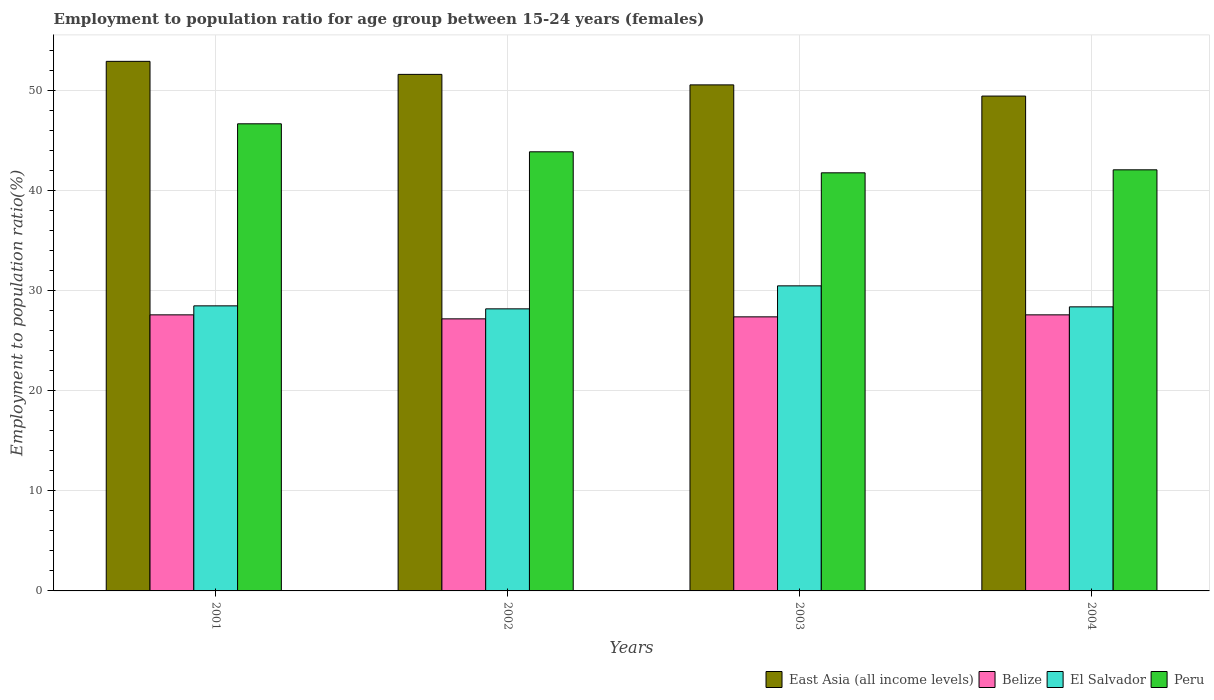How many groups of bars are there?
Make the answer very short. 4. Across all years, what is the maximum employment to population ratio in El Salvador?
Offer a terse response. 30.5. Across all years, what is the minimum employment to population ratio in El Salvador?
Your answer should be compact. 28.2. In which year was the employment to population ratio in El Salvador maximum?
Give a very brief answer. 2003. In which year was the employment to population ratio in Peru minimum?
Give a very brief answer. 2003. What is the total employment to population ratio in East Asia (all income levels) in the graph?
Give a very brief answer. 204.65. What is the difference between the employment to population ratio in Peru in 2001 and that in 2004?
Offer a terse response. 4.6. What is the difference between the employment to population ratio in Belize in 2003 and the employment to population ratio in Peru in 2001?
Provide a short and direct response. -19.3. What is the average employment to population ratio in El Salvador per year?
Your response must be concise. 28.9. In the year 2002, what is the difference between the employment to population ratio in Peru and employment to population ratio in Belize?
Offer a terse response. 16.7. In how many years, is the employment to population ratio in East Asia (all income levels) greater than 44 %?
Your answer should be compact. 4. What is the ratio of the employment to population ratio in Peru in 2003 to that in 2004?
Your response must be concise. 0.99. What is the difference between the highest and the second highest employment to population ratio in Peru?
Make the answer very short. 2.8. What is the difference between the highest and the lowest employment to population ratio in Peru?
Your answer should be compact. 4.9. In how many years, is the employment to population ratio in East Asia (all income levels) greater than the average employment to population ratio in East Asia (all income levels) taken over all years?
Offer a terse response. 2. What does the 2nd bar from the left in 2004 represents?
Provide a short and direct response. Belize. What does the 1st bar from the right in 2003 represents?
Your answer should be very brief. Peru. Is it the case that in every year, the sum of the employment to population ratio in East Asia (all income levels) and employment to population ratio in El Salvador is greater than the employment to population ratio in Belize?
Make the answer very short. Yes. Are the values on the major ticks of Y-axis written in scientific E-notation?
Your answer should be very brief. No. How many legend labels are there?
Provide a succinct answer. 4. What is the title of the graph?
Ensure brevity in your answer.  Employment to population ratio for age group between 15-24 years (females). What is the label or title of the Y-axis?
Your answer should be compact. Employment to population ratio(%). What is the Employment to population ratio(%) in East Asia (all income levels) in 2001?
Your response must be concise. 52.94. What is the Employment to population ratio(%) in Belize in 2001?
Your answer should be compact. 27.6. What is the Employment to population ratio(%) in El Salvador in 2001?
Offer a terse response. 28.5. What is the Employment to population ratio(%) in Peru in 2001?
Ensure brevity in your answer.  46.7. What is the Employment to population ratio(%) in East Asia (all income levels) in 2002?
Offer a terse response. 51.64. What is the Employment to population ratio(%) in Belize in 2002?
Your answer should be compact. 27.2. What is the Employment to population ratio(%) of El Salvador in 2002?
Give a very brief answer. 28.2. What is the Employment to population ratio(%) of Peru in 2002?
Offer a terse response. 43.9. What is the Employment to population ratio(%) of East Asia (all income levels) in 2003?
Offer a terse response. 50.59. What is the Employment to population ratio(%) in Belize in 2003?
Offer a terse response. 27.4. What is the Employment to population ratio(%) of El Salvador in 2003?
Your answer should be compact. 30.5. What is the Employment to population ratio(%) in Peru in 2003?
Ensure brevity in your answer.  41.8. What is the Employment to population ratio(%) of East Asia (all income levels) in 2004?
Provide a succinct answer. 49.47. What is the Employment to population ratio(%) of Belize in 2004?
Offer a very short reply. 27.6. What is the Employment to population ratio(%) in El Salvador in 2004?
Give a very brief answer. 28.4. What is the Employment to population ratio(%) of Peru in 2004?
Your response must be concise. 42.1. Across all years, what is the maximum Employment to population ratio(%) of East Asia (all income levels)?
Your answer should be very brief. 52.94. Across all years, what is the maximum Employment to population ratio(%) in Belize?
Ensure brevity in your answer.  27.6. Across all years, what is the maximum Employment to population ratio(%) in El Salvador?
Keep it short and to the point. 30.5. Across all years, what is the maximum Employment to population ratio(%) in Peru?
Keep it short and to the point. 46.7. Across all years, what is the minimum Employment to population ratio(%) of East Asia (all income levels)?
Make the answer very short. 49.47. Across all years, what is the minimum Employment to population ratio(%) of Belize?
Offer a terse response. 27.2. Across all years, what is the minimum Employment to population ratio(%) in El Salvador?
Keep it short and to the point. 28.2. Across all years, what is the minimum Employment to population ratio(%) in Peru?
Provide a succinct answer. 41.8. What is the total Employment to population ratio(%) in East Asia (all income levels) in the graph?
Ensure brevity in your answer.  204.65. What is the total Employment to population ratio(%) of Belize in the graph?
Provide a short and direct response. 109.8. What is the total Employment to population ratio(%) of El Salvador in the graph?
Provide a short and direct response. 115.6. What is the total Employment to population ratio(%) in Peru in the graph?
Give a very brief answer. 174.5. What is the difference between the Employment to population ratio(%) of East Asia (all income levels) in 2001 and that in 2002?
Your response must be concise. 1.3. What is the difference between the Employment to population ratio(%) of Belize in 2001 and that in 2002?
Keep it short and to the point. 0.4. What is the difference between the Employment to population ratio(%) in East Asia (all income levels) in 2001 and that in 2003?
Make the answer very short. 2.35. What is the difference between the Employment to population ratio(%) of El Salvador in 2001 and that in 2003?
Give a very brief answer. -2. What is the difference between the Employment to population ratio(%) of Peru in 2001 and that in 2003?
Give a very brief answer. 4.9. What is the difference between the Employment to population ratio(%) of East Asia (all income levels) in 2001 and that in 2004?
Ensure brevity in your answer.  3.47. What is the difference between the Employment to population ratio(%) of Peru in 2001 and that in 2004?
Your answer should be compact. 4.6. What is the difference between the Employment to population ratio(%) of East Asia (all income levels) in 2002 and that in 2003?
Provide a succinct answer. 1.05. What is the difference between the Employment to population ratio(%) of Belize in 2002 and that in 2003?
Give a very brief answer. -0.2. What is the difference between the Employment to population ratio(%) in El Salvador in 2002 and that in 2003?
Ensure brevity in your answer.  -2.3. What is the difference between the Employment to population ratio(%) of East Asia (all income levels) in 2002 and that in 2004?
Ensure brevity in your answer.  2.17. What is the difference between the Employment to population ratio(%) in El Salvador in 2002 and that in 2004?
Give a very brief answer. -0.2. What is the difference between the Employment to population ratio(%) of East Asia (all income levels) in 2003 and that in 2004?
Provide a succinct answer. 1.12. What is the difference between the Employment to population ratio(%) of Belize in 2003 and that in 2004?
Make the answer very short. -0.2. What is the difference between the Employment to population ratio(%) of Peru in 2003 and that in 2004?
Your answer should be very brief. -0.3. What is the difference between the Employment to population ratio(%) of East Asia (all income levels) in 2001 and the Employment to population ratio(%) of Belize in 2002?
Make the answer very short. 25.74. What is the difference between the Employment to population ratio(%) of East Asia (all income levels) in 2001 and the Employment to population ratio(%) of El Salvador in 2002?
Provide a short and direct response. 24.74. What is the difference between the Employment to population ratio(%) in East Asia (all income levels) in 2001 and the Employment to population ratio(%) in Peru in 2002?
Give a very brief answer. 9.04. What is the difference between the Employment to population ratio(%) in Belize in 2001 and the Employment to population ratio(%) in Peru in 2002?
Offer a terse response. -16.3. What is the difference between the Employment to population ratio(%) of El Salvador in 2001 and the Employment to population ratio(%) of Peru in 2002?
Keep it short and to the point. -15.4. What is the difference between the Employment to population ratio(%) in East Asia (all income levels) in 2001 and the Employment to population ratio(%) in Belize in 2003?
Your response must be concise. 25.54. What is the difference between the Employment to population ratio(%) in East Asia (all income levels) in 2001 and the Employment to population ratio(%) in El Salvador in 2003?
Keep it short and to the point. 22.44. What is the difference between the Employment to population ratio(%) in East Asia (all income levels) in 2001 and the Employment to population ratio(%) in Peru in 2003?
Your answer should be compact. 11.14. What is the difference between the Employment to population ratio(%) in East Asia (all income levels) in 2001 and the Employment to population ratio(%) in Belize in 2004?
Provide a succinct answer. 25.34. What is the difference between the Employment to population ratio(%) of East Asia (all income levels) in 2001 and the Employment to population ratio(%) of El Salvador in 2004?
Your answer should be compact. 24.54. What is the difference between the Employment to population ratio(%) in East Asia (all income levels) in 2001 and the Employment to population ratio(%) in Peru in 2004?
Keep it short and to the point. 10.84. What is the difference between the Employment to population ratio(%) in Belize in 2001 and the Employment to population ratio(%) in Peru in 2004?
Give a very brief answer. -14.5. What is the difference between the Employment to population ratio(%) in El Salvador in 2001 and the Employment to population ratio(%) in Peru in 2004?
Offer a very short reply. -13.6. What is the difference between the Employment to population ratio(%) of East Asia (all income levels) in 2002 and the Employment to population ratio(%) of Belize in 2003?
Make the answer very short. 24.24. What is the difference between the Employment to population ratio(%) of East Asia (all income levels) in 2002 and the Employment to population ratio(%) of El Salvador in 2003?
Make the answer very short. 21.14. What is the difference between the Employment to population ratio(%) of East Asia (all income levels) in 2002 and the Employment to population ratio(%) of Peru in 2003?
Offer a terse response. 9.84. What is the difference between the Employment to population ratio(%) of Belize in 2002 and the Employment to population ratio(%) of Peru in 2003?
Your answer should be compact. -14.6. What is the difference between the Employment to population ratio(%) of East Asia (all income levels) in 2002 and the Employment to population ratio(%) of Belize in 2004?
Offer a terse response. 24.04. What is the difference between the Employment to population ratio(%) in East Asia (all income levels) in 2002 and the Employment to population ratio(%) in El Salvador in 2004?
Offer a terse response. 23.24. What is the difference between the Employment to population ratio(%) in East Asia (all income levels) in 2002 and the Employment to population ratio(%) in Peru in 2004?
Your answer should be very brief. 9.54. What is the difference between the Employment to population ratio(%) in Belize in 2002 and the Employment to population ratio(%) in El Salvador in 2004?
Your answer should be compact. -1.2. What is the difference between the Employment to population ratio(%) of Belize in 2002 and the Employment to population ratio(%) of Peru in 2004?
Make the answer very short. -14.9. What is the difference between the Employment to population ratio(%) of East Asia (all income levels) in 2003 and the Employment to population ratio(%) of Belize in 2004?
Offer a terse response. 22.99. What is the difference between the Employment to population ratio(%) in East Asia (all income levels) in 2003 and the Employment to population ratio(%) in El Salvador in 2004?
Ensure brevity in your answer.  22.19. What is the difference between the Employment to population ratio(%) in East Asia (all income levels) in 2003 and the Employment to population ratio(%) in Peru in 2004?
Give a very brief answer. 8.49. What is the difference between the Employment to population ratio(%) of Belize in 2003 and the Employment to population ratio(%) of El Salvador in 2004?
Your answer should be compact. -1. What is the difference between the Employment to population ratio(%) of Belize in 2003 and the Employment to population ratio(%) of Peru in 2004?
Provide a succinct answer. -14.7. What is the difference between the Employment to population ratio(%) in El Salvador in 2003 and the Employment to population ratio(%) in Peru in 2004?
Give a very brief answer. -11.6. What is the average Employment to population ratio(%) of East Asia (all income levels) per year?
Make the answer very short. 51.16. What is the average Employment to population ratio(%) in Belize per year?
Make the answer very short. 27.45. What is the average Employment to population ratio(%) of El Salvador per year?
Offer a very short reply. 28.9. What is the average Employment to population ratio(%) of Peru per year?
Keep it short and to the point. 43.62. In the year 2001, what is the difference between the Employment to population ratio(%) of East Asia (all income levels) and Employment to population ratio(%) of Belize?
Offer a terse response. 25.34. In the year 2001, what is the difference between the Employment to population ratio(%) of East Asia (all income levels) and Employment to population ratio(%) of El Salvador?
Keep it short and to the point. 24.44. In the year 2001, what is the difference between the Employment to population ratio(%) of East Asia (all income levels) and Employment to population ratio(%) of Peru?
Offer a terse response. 6.24. In the year 2001, what is the difference between the Employment to population ratio(%) of Belize and Employment to population ratio(%) of El Salvador?
Provide a short and direct response. -0.9. In the year 2001, what is the difference between the Employment to population ratio(%) in Belize and Employment to population ratio(%) in Peru?
Make the answer very short. -19.1. In the year 2001, what is the difference between the Employment to population ratio(%) in El Salvador and Employment to population ratio(%) in Peru?
Your response must be concise. -18.2. In the year 2002, what is the difference between the Employment to population ratio(%) of East Asia (all income levels) and Employment to population ratio(%) of Belize?
Give a very brief answer. 24.44. In the year 2002, what is the difference between the Employment to population ratio(%) of East Asia (all income levels) and Employment to population ratio(%) of El Salvador?
Provide a succinct answer. 23.44. In the year 2002, what is the difference between the Employment to population ratio(%) in East Asia (all income levels) and Employment to population ratio(%) in Peru?
Provide a short and direct response. 7.74. In the year 2002, what is the difference between the Employment to population ratio(%) of Belize and Employment to population ratio(%) of El Salvador?
Provide a succinct answer. -1. In the year 2002, what is the difference between the Employment to population ratio(%) of Belize and Employment to population ratio(%) of Peru?
Keep it short and to the point. -16.7. In the year 2002, what is the difference between the Employment to population ratio(%) in El Salvador and Employment to population ratio(%) in Peru?
Your response must be concise. -15.7. In the year 2003, what is the difference between the Employment to population ratio(%) of East Asia (all income levels) and Employment to population ratio(%) of Belize?
Provide a short and direct response. 23.19. In the year 2003, what is the difference between the Employment to population ratio(%) in East Asia (all income levels) and Employment to population ratio(%) in El Salvador?
Your answer should be compact. 20.09. In the year 2003, what is the difference between the Employment to population ratio(%) of East Asia (all income levels) and Employment to population ratio(%) of Peru?
Make the answer very short. 8.79. In the year 2003, what is the difference between the Employment to population ratio(%) in Belize and Employment to population ratio(%) in Peru?
Make the answer very short. -14.4. In the year 2004, what is the difference between the Employment to population ratio(%) in East Asia (all income levels) and Employment to population ratio(%) in Belize?
Your answer should be very brief. 21.87. In the year 2004, what is the difference between the Employment to population ratio(%) in East Asia (all income levels) and Employment to population ratio(%) in El Salvador?
Provide a short and direct response. 21.07. In the year 2004, what is the difference between the Employment to population ratio(%) in East Asia (all income levels) and Employment to population ratio(%) in Peru?
Give a very brief answer. 7.37. In the year 2004, what is the difference between the Employment to population ratio(%) in Belize and Employment to population ratio(%) in Peru?
Provide a succinct answer. -14.5. In the year 2004, what is the difference between the Employment to population ratio(%) of El Salvador and Employment to population ratio(%) of Peru?
Offer a terse response. -13.7. What is the ratio of the Employment to population ratio(%) in East Asia (all income levels) in 2001 to that in 2002?
Give a very brief answer. 1.03. What is the ratio of the Employment to population ratio(%) of Belize in 2001 to that in 2002?
Your response must be concise. 1.01. What is the ratio of the Employment to population ratio(%) of El Salvador in 2001 to that in 2002?
Your response must be concise. 1.01. What is the ratio of the Employment to population ratio(%) of Peru in 2001 to that in 2002?
Your answer should be very brief. 1.06. What is the ratio of the Employment to population ratio(%) of East Asia (all income levels) in 2001 to that in 2003?
Offer a very short reply. 1.05. What is the ratio of the Employment to population ratio(%) in Belize in 2001 to that in 2003?
Ensure brevity in your answer.  1.01. What is the ratio of the Employment to population ratio(%) in El Salvador in 2001 to that in 2003?
Your answer should be compact. 0.93. What is the ratio of the Employment to population ratio(%) in Peru in 2001 to that in 2003?
Offer a terse response. 1.12. What is the ratio of the Employment to population ratio(%) in East Asia (all income levels) in 2001 to that in 2004?
Give a very brief answer. 1.07. What is the ratio of the Employment to population ratio(%) of Belize in 2001 to that in 2004?
Your answer should be compact. 1. What is the ratio of the Employment to population ratio(%) of El Salvador in 2001 to that in 2004?
Provide a succinct answer. 1. What is the ratio of the Employment to population ratio(%) of Peru in 2001 to that in 2004?
Your response must be concise. 1.11. What is the ratio of the Employment to population ratio(%) in East Asia (all income levels) in 2002 to that in 2003?
Provide a succinct answer. 1.02. What is the ratio of the Employment to population ratio(%) of Belize in 2002 to that in 2003?
Keep it short and to the point. 0.99. What is the ratio of the Employment to population ratio(%) in El Salvador in 2002 to that in 2003?
Give a very brief answer. 0.92. What is the ratio of the Employment to population ratio(%) of Peru in 2002 to that in 2003?
Provide a short and direct response. 1.05. What is the ratio of the Employment to population ratio(%) of East Asia (all income levels) in 2002 to that in 2004?
Provide a succinct answer. 1.04. What is the ratio of the Employment to population ratio(%) in Belize in 2002 to that in 2004?
Your answer should be very brief. 0.99. What is the ratio of the Employment to population ratio(%) of Peru in 2002 to that in 2004?
Provide a succinct answer. 1.04. What is the ratio of the Employment to population ratio(%) in East Asia (all income levels) in 2003 to that in 2004?
Your response must be concise. 1.02. What is the ratio of the Employment to population ratio(%) of Belize in 2003 to that in 2004?
Your response must be concise. 0.99. What is the ratio of the Employment to population ratio(%) in El Salvador in 2003 to that in 2004?
Offer a terse response. 1.07. What is the ratio of the Employment to population ratio(%) in Peru in 2003 to that in 2004?
Your answer should be very brief. 0.99. What is the difference between the highest and the second highest Employment to population ratio(%) of East Asia (all income levels)?
Your response must be concise. 1.3. What is the difference between the highest and the second highest Employment to population ratio(%) of Peru?
Give a very brief answer. 2.8. What is the difference between the highest and the lowest Employment to population ratio(%) of East Asia (all income levels)?
Provide a short and direct response. 3.47. What is the difference between the highest and the lowest Employment to population ratio(%) of Belize?
Your answer should be compact. 0.4. What is the difference between the highest and the lowest Employment to population ratio(%) of El Salvador?
Ensure brevity in your answer.  2.3. 